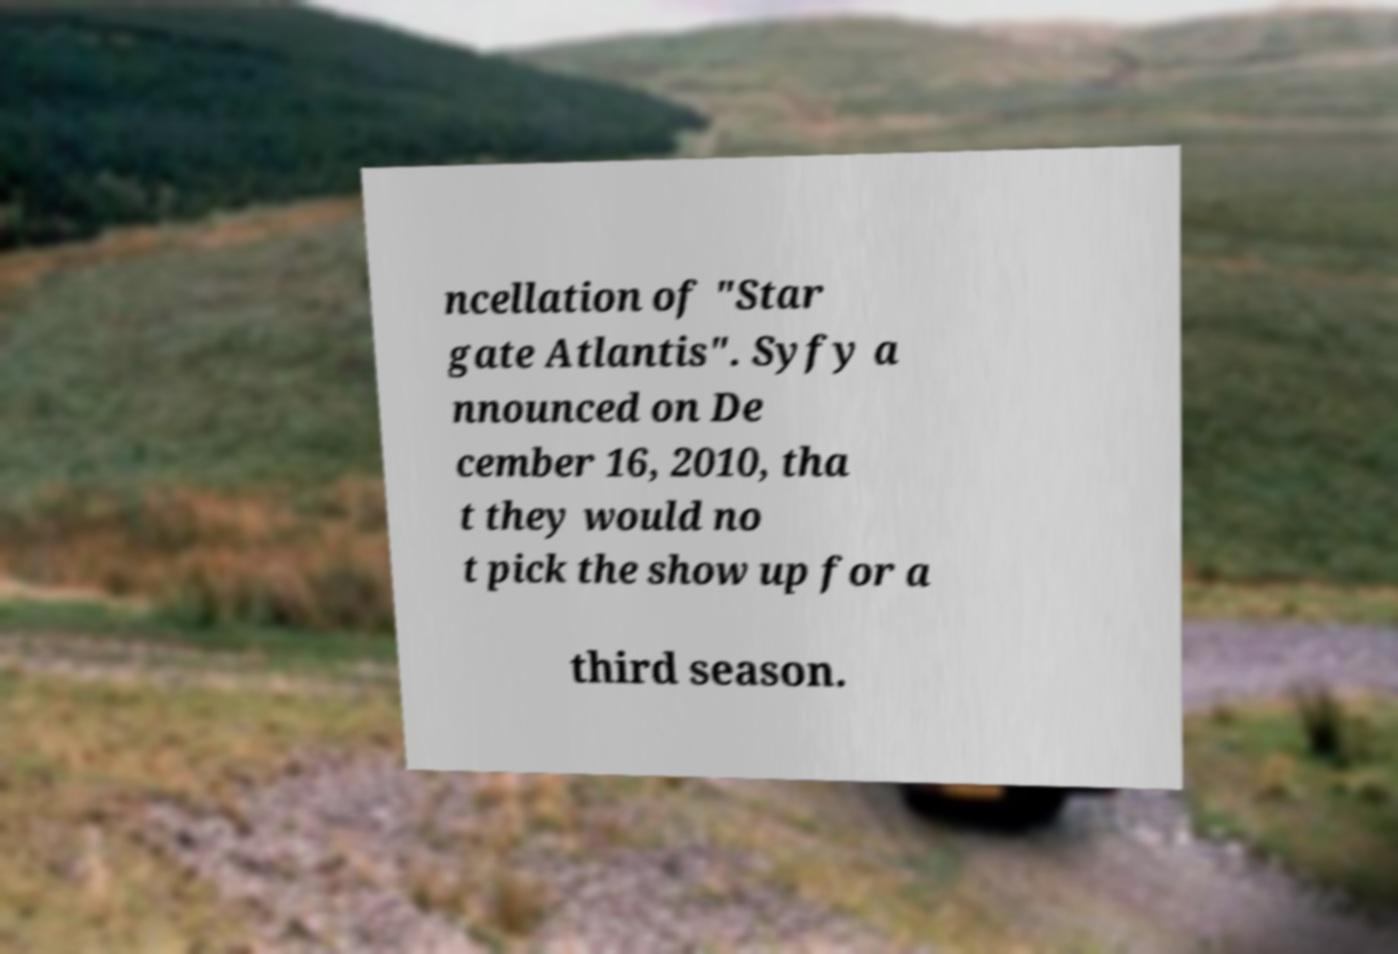Please read and relay the text visible in this image. What does it say? ncellation of "Star gate Atlantis". Syfy a nnounced on De cember 16, 2010, tha t they would no t pick the show up for a third season. 